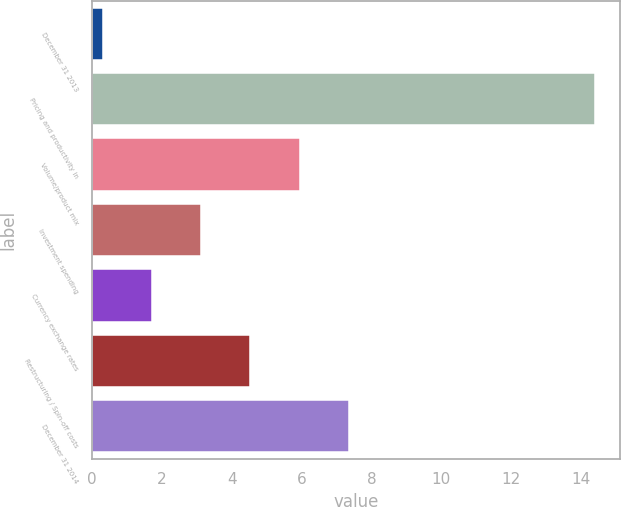Convert chart to OTSL. <chart><loc_0><loc_0><loc_500><loc_500><bar_chart><fcel>December 31 2013<fcel>Pricing and productivity in<fcel>Volume/product mix<fcel>Investment spending<fcel>Currency exchange rates<fcel>Restructuring / Spin-off costs<fcel>December 31 2014<nl><fcel>0.3<fcel>14.4<fcel>5.94<fcel>3.12<fcel>1.71<fcel>4.53<fcel>7.35<nl></chart> 